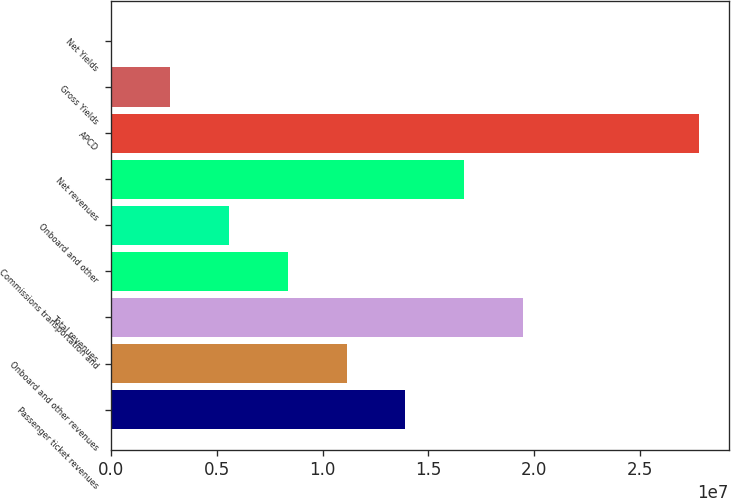Convert chart. <chart><loc_0><loc_0><loc_500><loc_500><bar_chart><fcel>Passenger ticket revenues<fcel>Onboard and other revenues<fcel>Total revenues<fcel>Commissions transportation and<fcel>Onboard and other<fcel>Net revenues<fcel>APCD<fcel>Gross Yields<fcel>Net Yields<nl><fcel>1.39107e+07<fcel>1.11286e+07<fcel>1.94749e+07<fcel>8.34648e+06<fcel>5.56437e+06<fcel>1.66928e+07<fcel>2.78212e+07<fcel>2.78226e+06<fcel>158.27<nl></chart> 